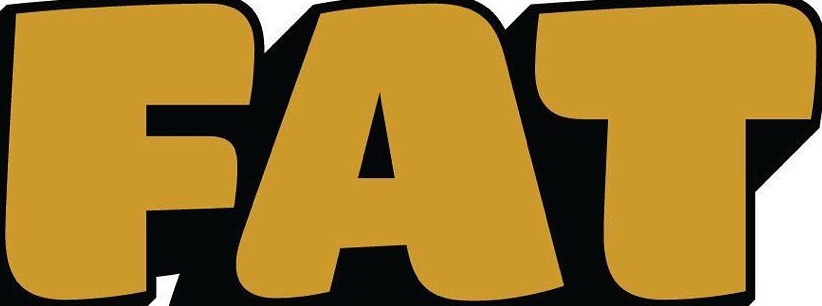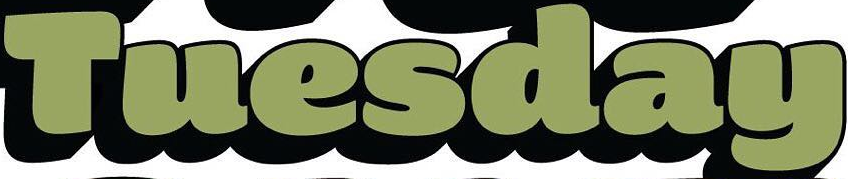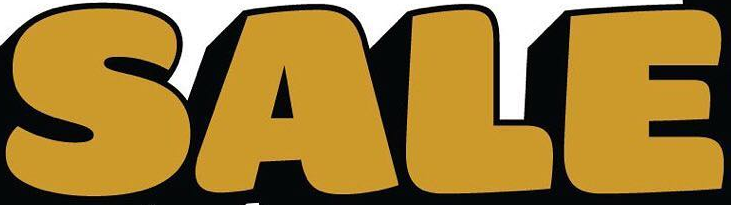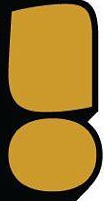What text is displayed in these images sequentially, separated by a semicolon? FAT; Tuesday; SALE; ! 